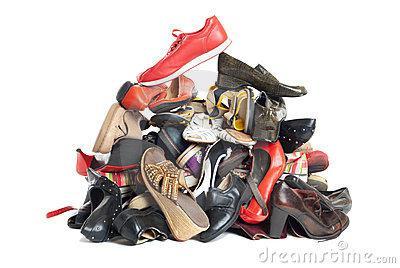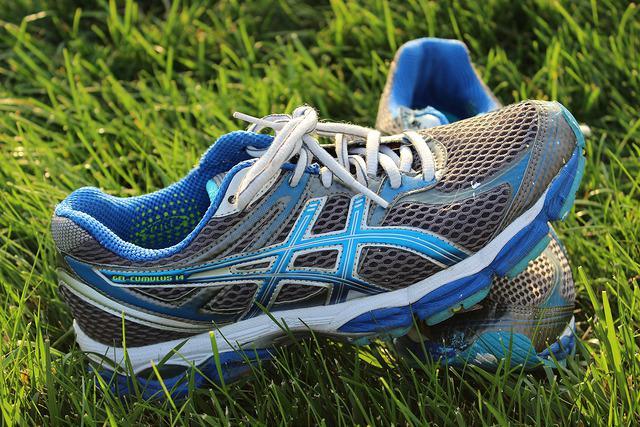The first image is the image on the left, the second image is the image on the right. Examine the images to the left and right. Is the description "Shoes are piled up together in the image on the right." accurate? Answer yes or no. No. The first image is the image on the left, the second image is the image on the right. Assess this claim about the two images: "One image shows a pair of sneakers and the other shows a shoe pyramid.". Correct or not? Answer yes or no. Yes. 